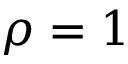<formula> <loc_0><loc_0><loc_500><loc_500>\rho = 1</formula> 